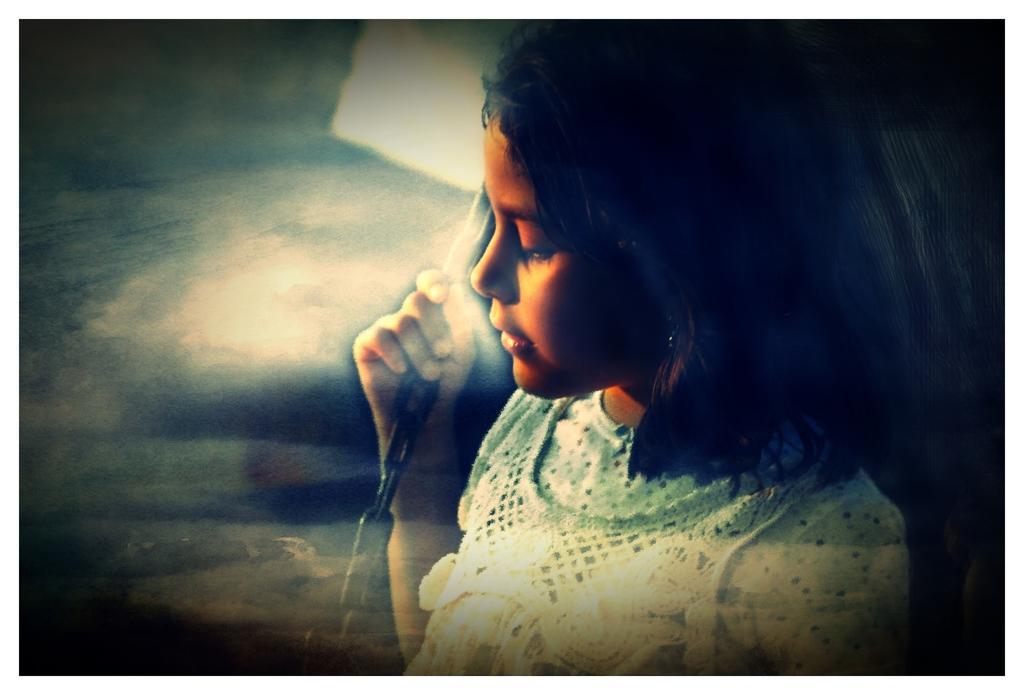How would you summarize this image in a sentence or two? In this image there is a girl. She is holding a chain in her hand. To the left it is blurry. 